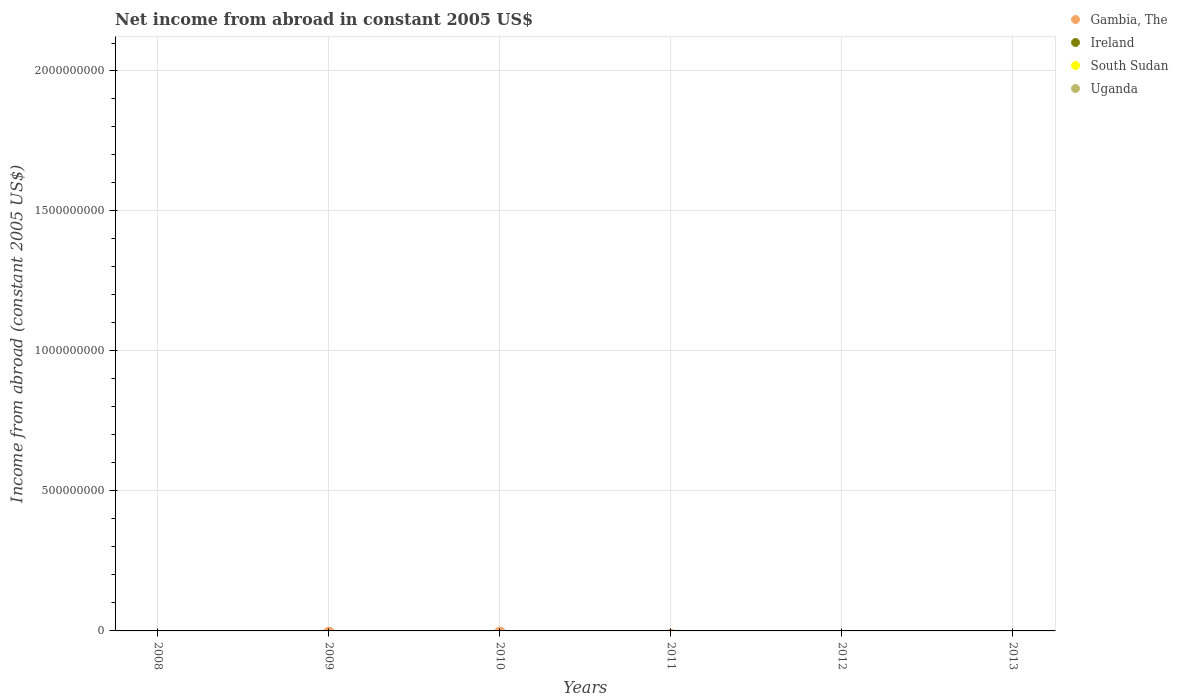What is the net income from abroad in Ireland in 2011?
Ensure brevity in your answer.  0. What is the total net income from abroad in Uganda in the graph?
Ensure brevity in your answer.  0. What is the difference between the net income from abroad in South Sudan in 2013 and the net income from abroad in Gambia, The in 2010?
Offer a very short reply. 0. Is the net income from abroad in Gambia, The strictly greater than the net income from abroad in South Sudan over the years?
Make the answer very short. Yes. Is the net income from abroad in Uganda strictly less than the net income from abroad in South Sudan over the years?
Provide a short and direct response. No. How many dotlines are there?
Provide a succinct answer. 0. Are the values on the major ticks of Y-axis written in scientific E-notation?
Your answer should be compact. No. Does the graph contain grids?
Provide a short and direct response. Yes. What is the title of the graph?
Make the answer very short. Net income from abroad in constant 2005 US$. What is the label or title of the X-axis?
Offer a terse response. Years. What is the label or title of the Y-axis?
Your answer should be compact. Income from abroad (constant 2005 US$). What is the Income from abroad (constant 2005 US$) of Ireland in 2008?
Your answer should be very brief. 0. What is the Income from abroad (constant 2005 US$) of Gambia, The in 2009?
Give a very brief answer. 0. What is the Income from abroad (constant 2005 US$) in Ireland in 2009?
Your response must be concise. 0. What is the Income from abroad (constant 2005 US$) of Uganda in 2009?
Ensure brevity in your answer.  0. What is the Income from abroad (constant 2005 US$) of Ireland in 2010?
Your answer should be very brief. 0. What is the Income from abroad (constant 2005 US$) in South Sudan in 2010?
Your response must be concise. 0. What is the Income from abroad (constant 2005 US$) of Gambia, The in 2011?
Provide a short and direct response. 0. What is the Income from abroad (constant 2005 US$) of South Sudan in 2011?
Provide a short and direct response. 0. What is the Income from abroad (constant 2005 US$) of Uganda in 2011?
Ensure brevity in your answer.  0. What is the Income from abroad (constant 2005 US$) of Gambia, The in 2012?
Give a very brief answer. 0. What is the Income from abroad (constant 2005 US$) of South Sudan in 2012?
Provide a short and direct response. 0. What is the Income from abroad (constant 2005 US$) in Uganda in 2012?
Keep it short and to the point. 0. What is the Income from abroad (constant 2005 US$) in Ireland in 2013?
Offer a very short reply. 0. What is the total Income from abroad (constant 2005 US$) in Gambia, The in the graph?
Keep it short and to the point. 0. What is the total Income from abroad (constant 2005 US$) in Ireland in the graph?
Your answer should be compact. 0. What is the total Income from abroad (constant 2005 US$) of South Sudan in the graph?
Ensure brevity in your answer.  0. What is the average Income from abroad (constant 2005 US$) in Uganda per year?
Ensure brevity in your answer.  0. 